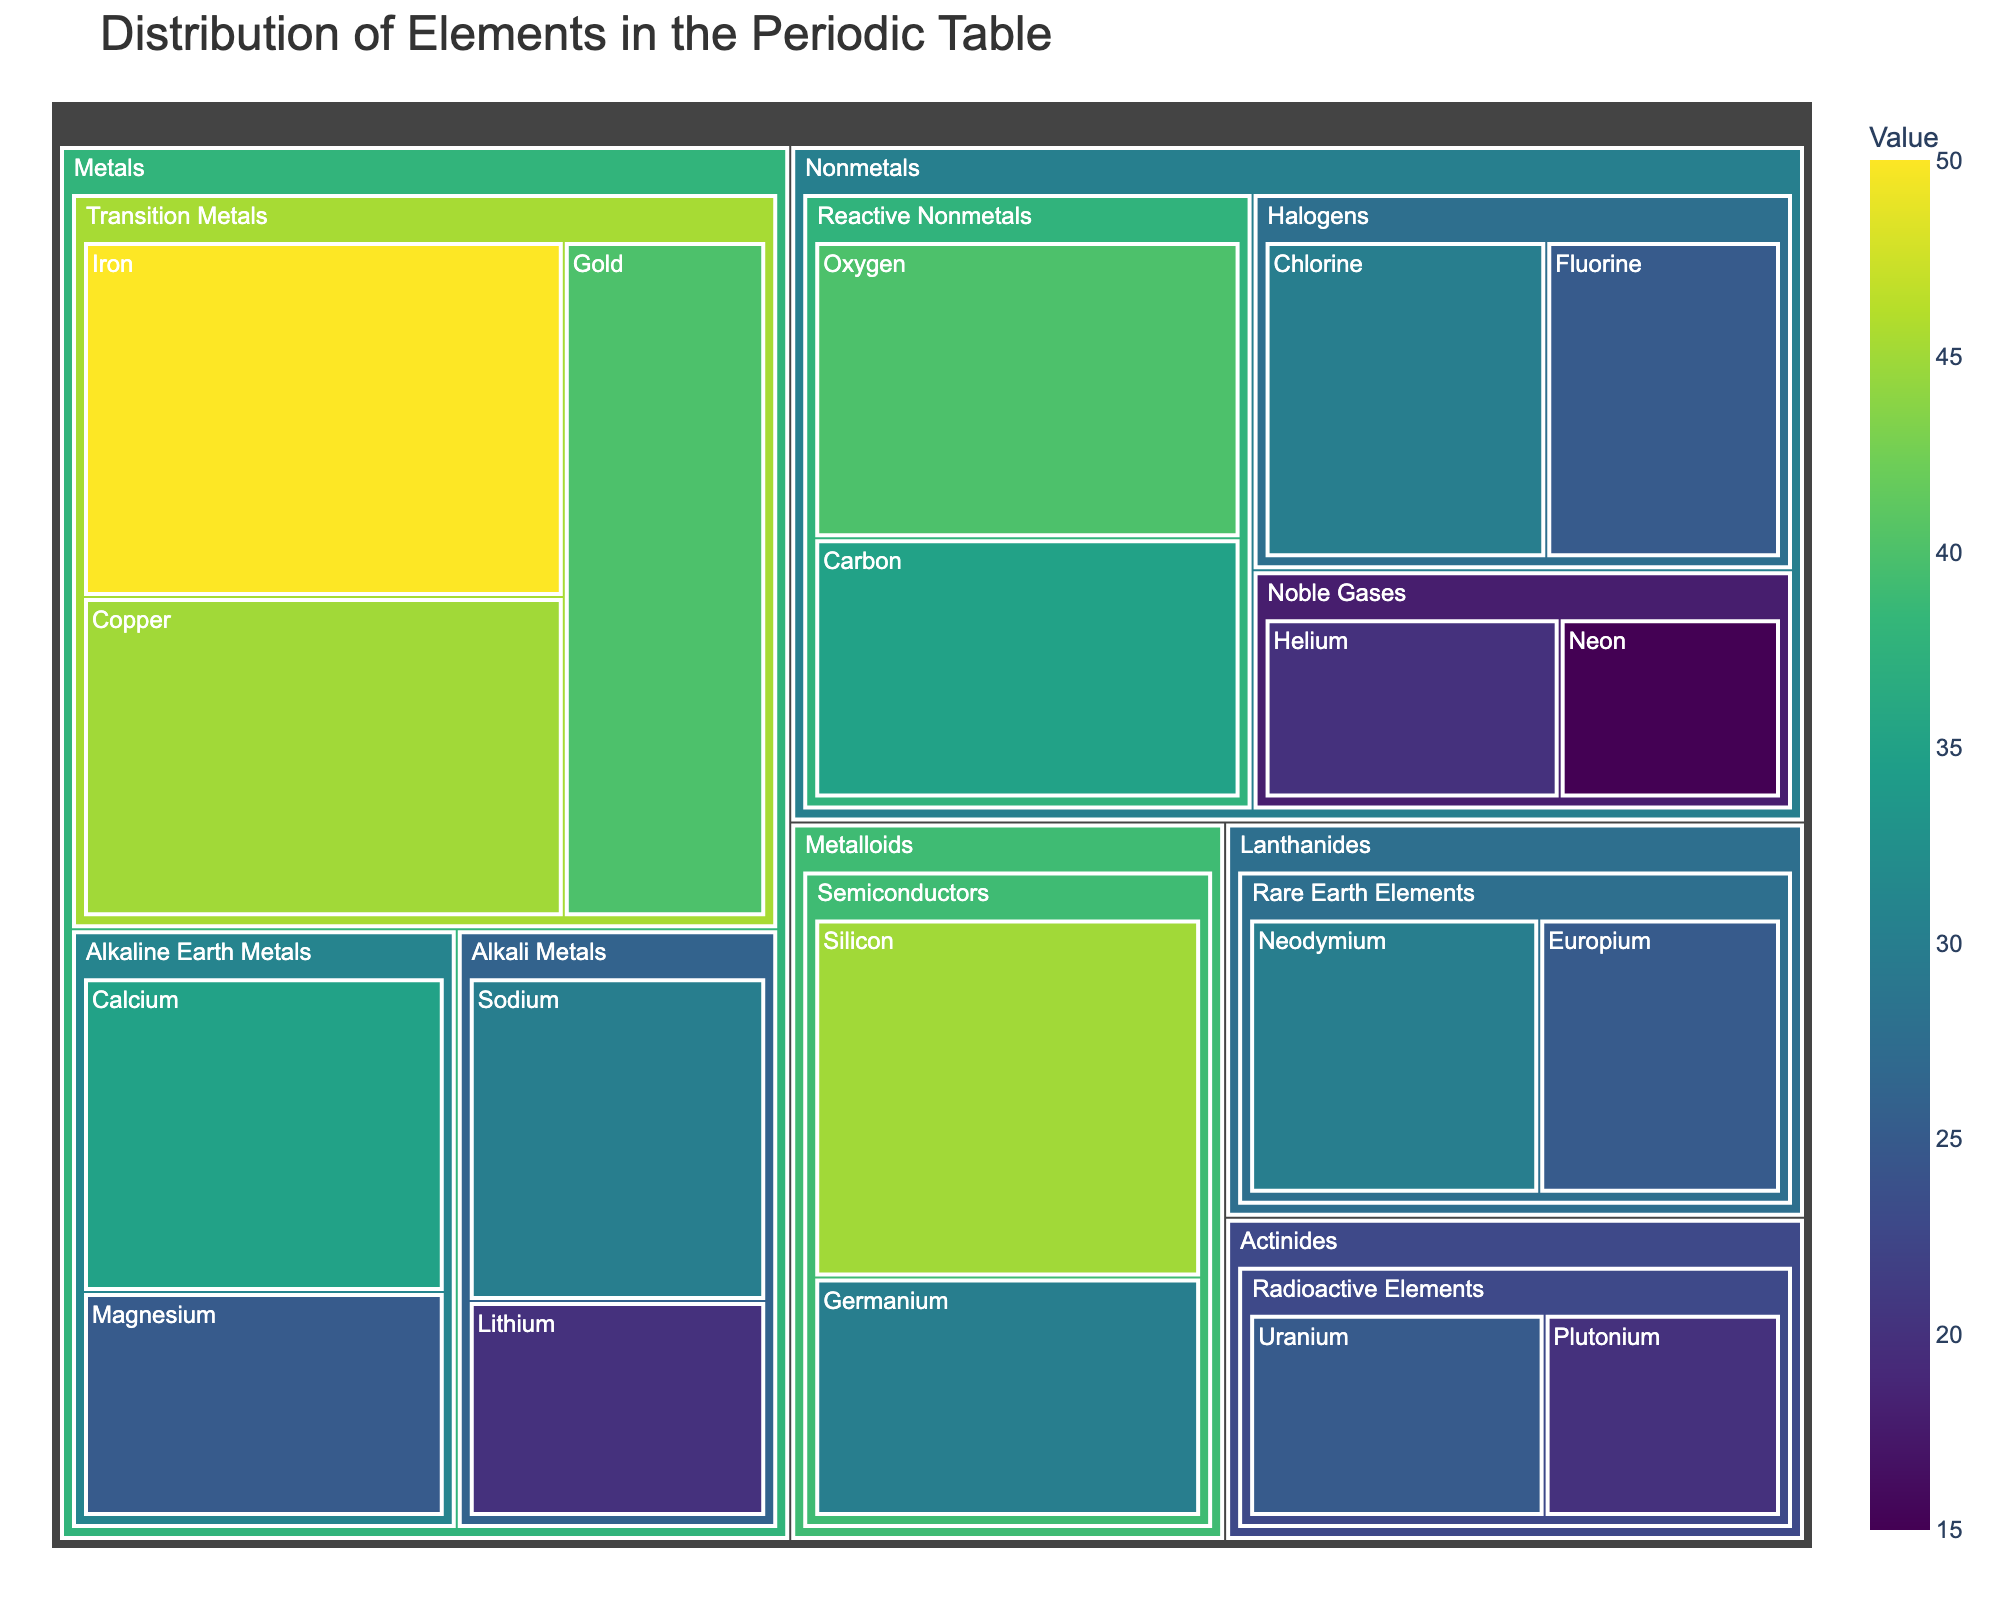What's the title of the figure? You can see the title at the top of the figure, which is usually set in a larger font for prominence.
Answer: Distribution of Elements in the Periodic Table Which group contains the element with the highest value? Look for the element with the largest area in the treemap and check the group it's under. In this case, "Iron" has the highest value, and it is under the "Metals" group.
Answer: Metals Which element in the Noble Gases subgroup has the smallest value? Find the Noble Gases subgroup and compare the values of the elements "Helium" and "Neon".
Answer: Neon What is the total value of elements in the Reactive Nonmetals subgroup? Add the values of "Oxygen" and "Carbon" which are in the Reactive Nonmetals subgroup: 40 + 35.
Answer: 75 What is the difference in value between Sodium and Magnesium? Find the values of Sodium (30) and Magnesium (25), then subtract the smaller from the larger: 30 - 25.
Answer: 5 Which group contains the most elements? Count the number of elements within each group to find the one with the most elements. Metals have 7 elements which is the highest.
Answer: Metals Compare the value of Silicon and Germanium in the Semiconductors subgroup. Which one is higher? Observe the sizes of the treemap areas for Silicon and Germanium, and compare their values: 45 for Silicon, 30 for Germanium.
Answer: Silicon What's the average value of elements in the Halogens subgroup? Add the values of Chlorine (30) and Fluorine (25), then divide by the number of elements: (30 + 25) / 2.
Answer: 27.5 How does the value of Gold compare to that of Uranium? Compare the values of Gold (40) and Uranium (25) directly.
Answer: Gold is greater than Uranium What is the combined value of elements in the Lanthanides group? Sum the values of Neodymium and Europium: 30 + 25.
Answer: 55 